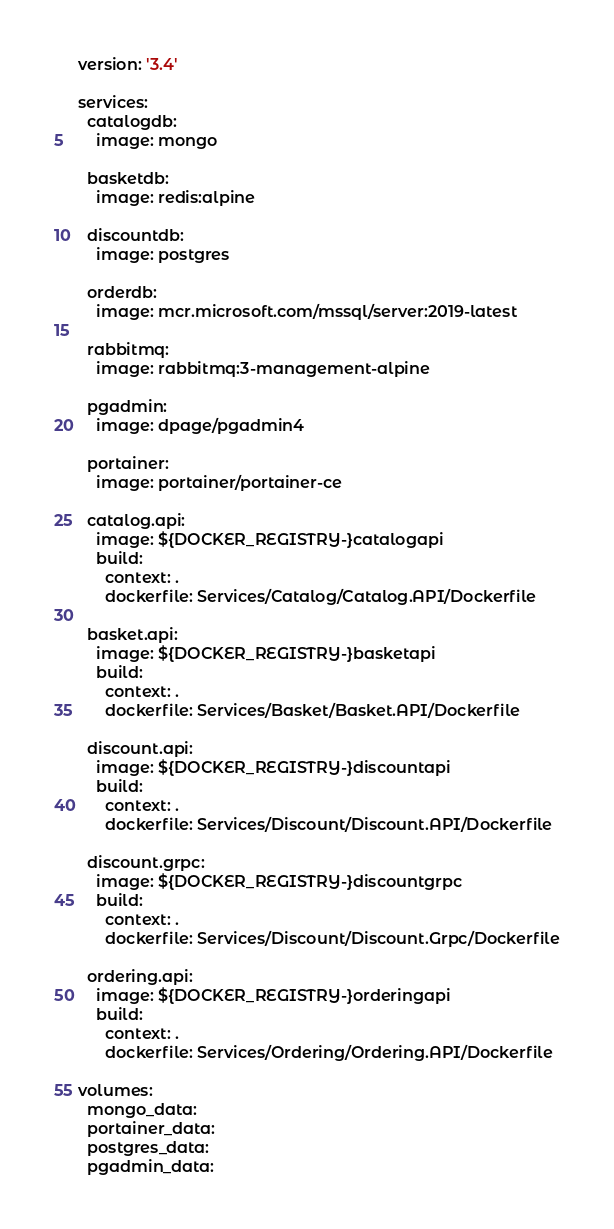Convert code to text. <code><loc_0><loc_0><loc_500><loc_500><_YAML_>version: '3.4'

services:
  catalogdb:
    image: mongo

  basketdb:
    image: redis:alpine

  discountdb:
    image: postgres

  orderdb:
    image: mcr.microsoft.com/mssql/server:2019-latest

  rabbitmq:
    image: rabbitmq:3-management-alpine

  pgadmin:
    image: dpage/pgadmin4

  portainer:
    image: portainer/portainer-ce

  catalog.api:
    image: ${DOCKER_REGISTRY-}catalogapi
    build:
      context: .
      dockerfile: Services/Catalog/Catalog.API/Dockerfile

  basket.api:
    image: ${DOCKER_REGISTRY-}basketapi
    build:
      context: .
      dockerfile: Services/Basket/Basket.API/Dockerfile

  discount.api:
    image: ${DOCKER_REGISTRY-}discountapi
    build:
      context: .
      dockerfile: Services/Discount/Discount.API/Dockerfile

  discount.grpc:
    image: ${DOCKER_REGISTRY-}discountgrpc
    build:
      context: .
      dockerfile: Services/Discount/Discount.Grpc/Dockerfile

  ordering.api:
    image: ${DOCKER_REGISTRY-}orderingapi
    build:
      context: .
      dockerfile: Services/Ordering/Ordering.API/Dockerfile

volumes:
  mongo_data: 
  portainer_data:
  postgres_data:
  pgadmin_data:



</code> 